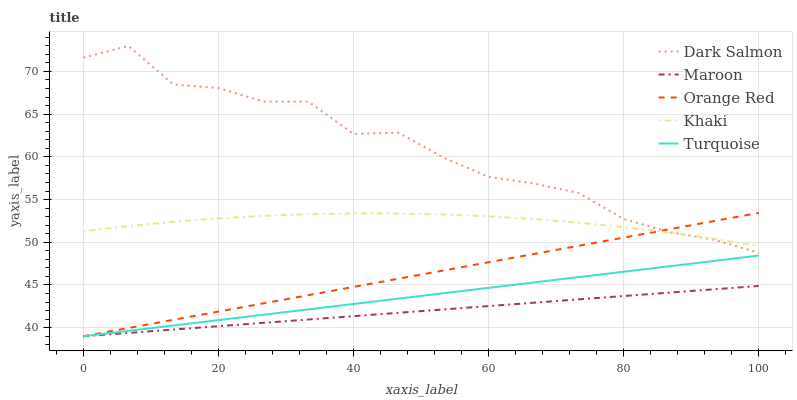Does Maroon have the minimum area under the curve?
Answer yes or no. Yes. Does Dark Salmon have the maximum area under the curve?
Answer yes or no. Yes. Does Khaki have the minimum area under the curve?
Answer yes or no. No. Does Khaki have the maximum area under the curve?
Answer yes or no. No. Is Turquoise the smoothest?
Answer yes or no. Yes. Is Dark Salmon the roughest?
Answer yes or no. Yes. Is Khaki the smoothest?
Answer yes or no. No. Is Khaki the roughest?
Answer yes or no. No. Does Turquoise have the lowest value?
Answer yes or no. Yes. Does Dark Salmon have the lowest value?
Answer yes or no. No. Does Dark Salmon have the highest value?
Answer yes or no. Yes. Does Khaki have the highest value?
Answer yes or no. No. Is Maroon less than Dark Salmon?
Answer yes or no. Yes. Is Khaki greater than Maroon?
Answer yes or no. Yes. Does Khaki intersect Dark Salmon?
Answer yes or no. Yes. Is Khaki less than Dark Salmon?
Answer yes or no. No. Is Khaki greater than Dark Salmon?
Answer yes or no. No. Does Maroon intersect Dark Salmon?
Answer yes or no. No. 